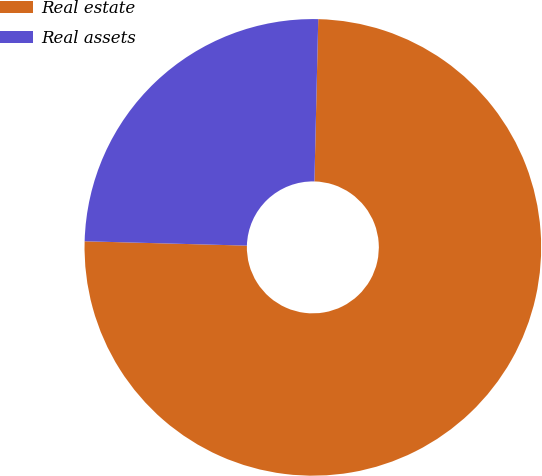Convert chart to OTSL. <chart><loc_0><loc_0><loc_500><loc_500><pie_chart><fcel>Real estate<fcel>Real assets<nl><fcel>75.05%<fcel>24.95%<nl></chart> 